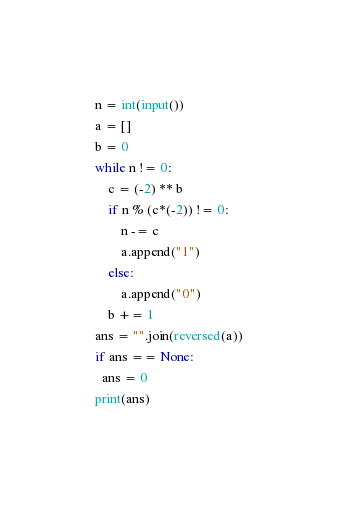<code> <loc_0><loc_0><loc_500><loc_500><_Python_>n = int(input())
a = []
b = 0
while n != 0:
    c = (-2) ** b
    if n % (c*(-2)) != 0:
        n -= c
        a.append("1")
    else:
        a.append("0")
    b += 1
ans = "".join(reversed(a))
if ans == None:
  ans = 0
print(ans)</code> 